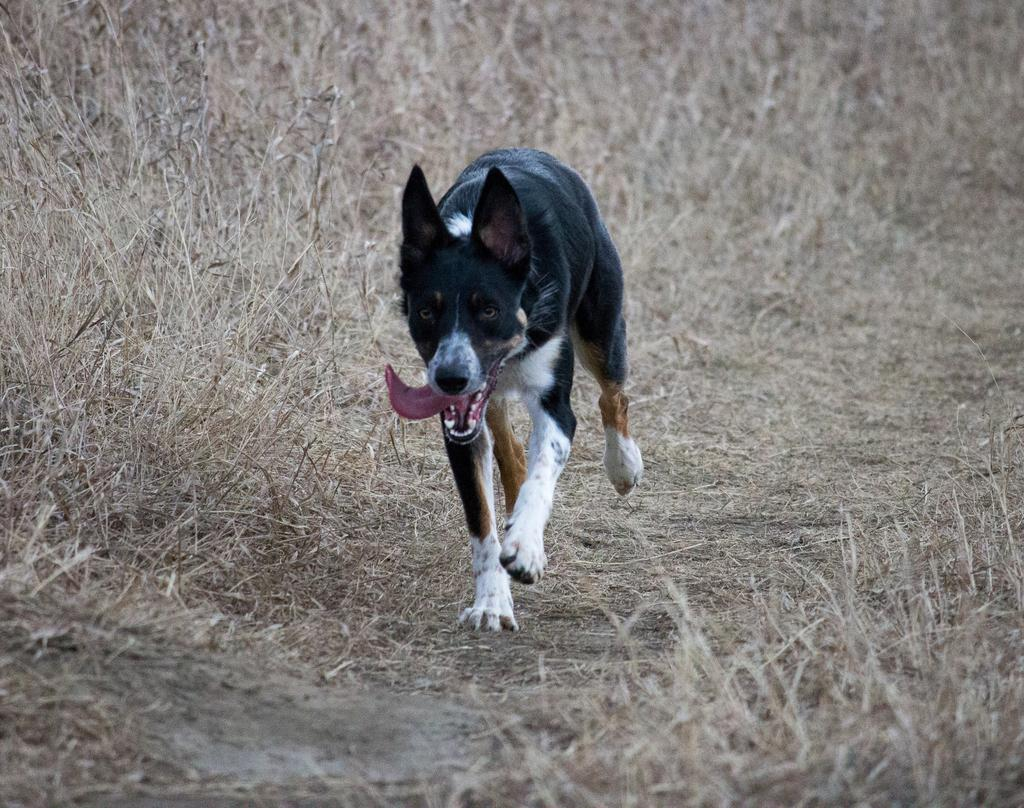What type of surface is visible in the image? There is ground visible in the image. What animal can be seen on the ground? There is a black and white dog standing on the ground. What is the color of the grass in the image? The grass in the image is yellow. Can you see any adjustments being made by the cat in the image? There is no cat present in the image, so no adjustments can be observed. 